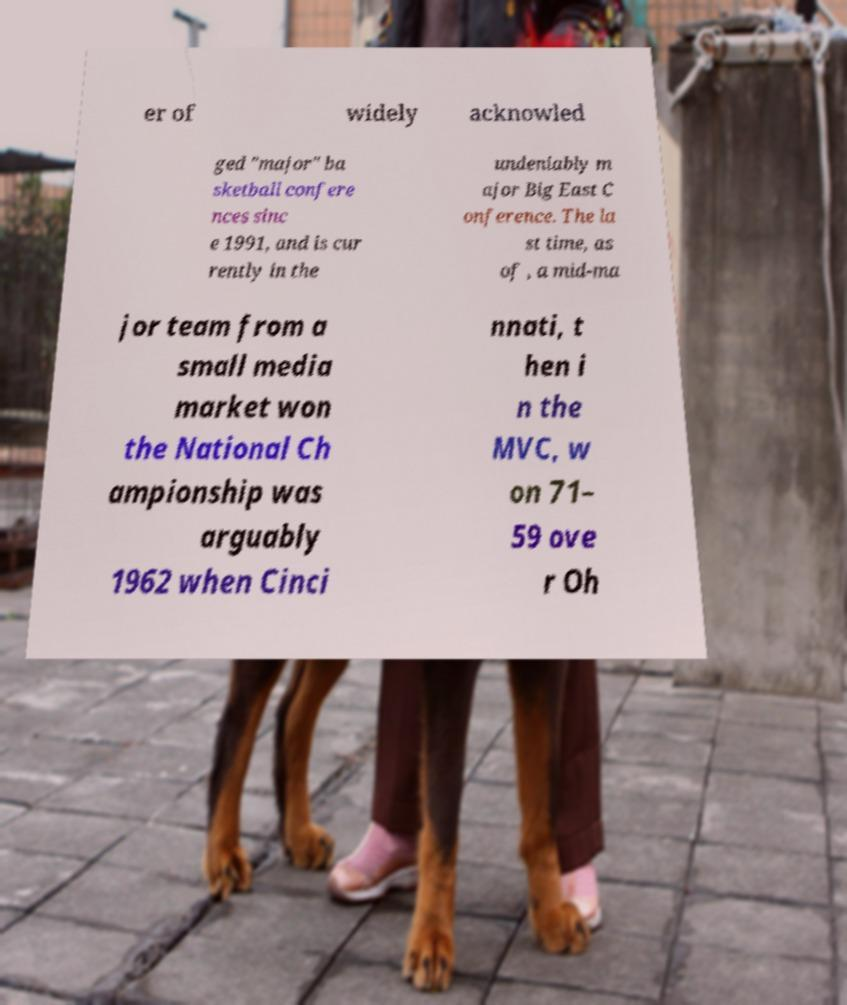There's text embedded in this image that I need extracted. Can you transcribe it verbatim? er of widely acknowled ged "major" ba sketball confere nces sinc e 1991, and is cur rently in the undeniably m ajor Big East C onference. The la st time, as of , a mid-ma jor team from a small media market won the National Ch ampionship was arguably 1962 when Cinci nnati, t hen i n the MVC, w on 71– 59 ove r Oh 